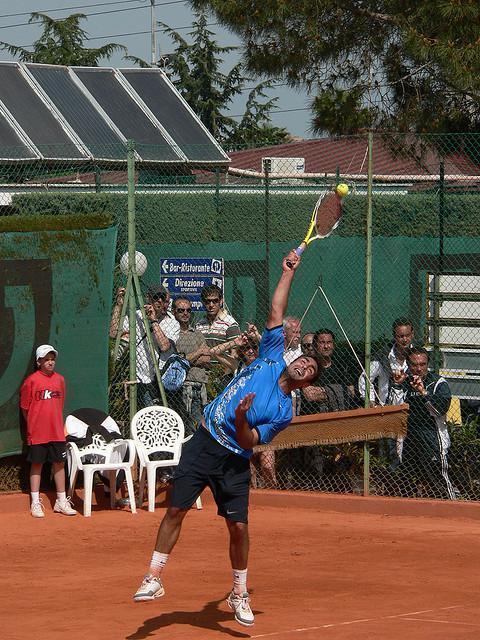What powers the lights here?
Indicate the correct response and explain using: 'Answer: answer
Rationale: rationale.'
Options: Hot water, oil, gas, solar panels. Answer: solar panels.
Rationale: There are visible solar panels in the top left corner. this is a source of power and happens to be the only one visible. Why is his arm so high in the air?
Make your selection from the four choices given to correctly answer the question.
Options: Unbalanced, hit ball, wants attention, arm broken. Hit ball. 